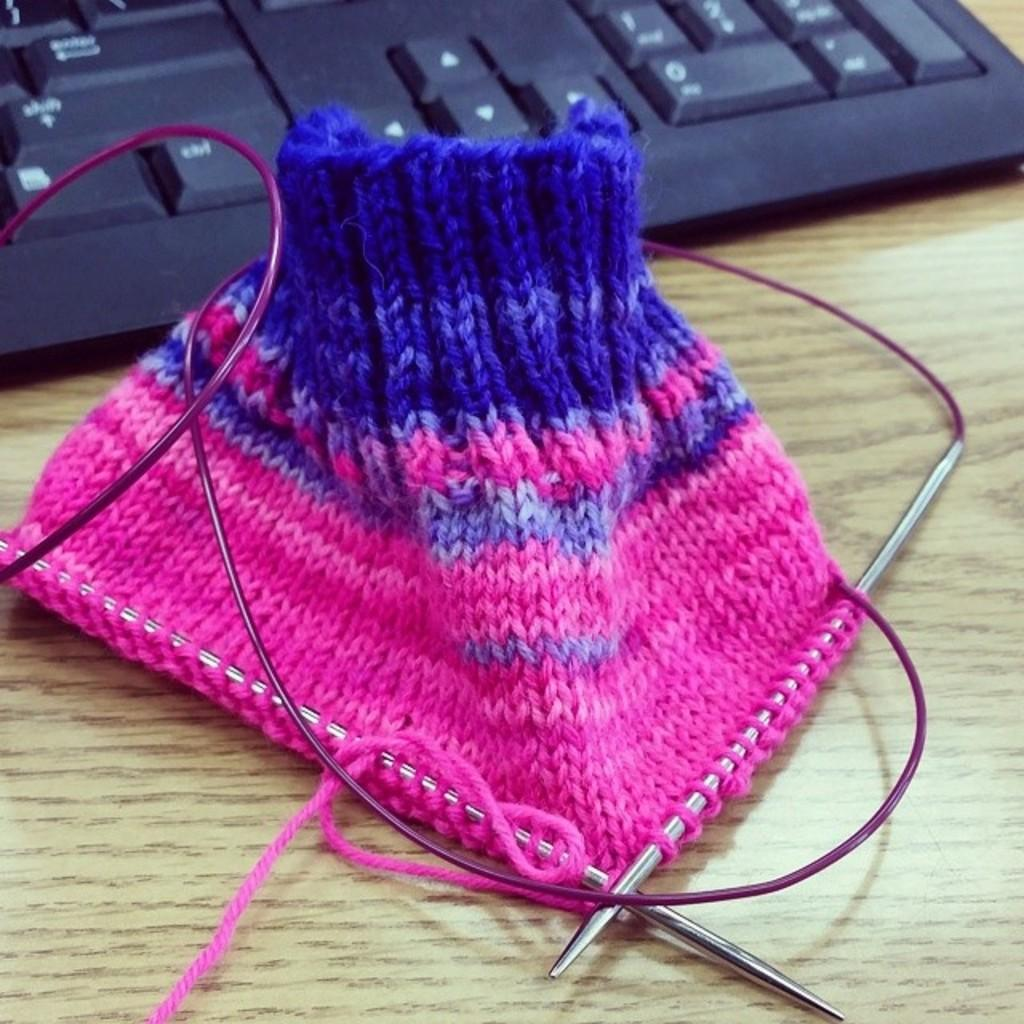What type of material is present in the image? There is cloth in the image. What tools are used for sewing that can be seen in the image? Sewing needles are visible in the image. What electronic device is present in the image? There is a keyboard in the image. What surface are the objects placed on in the image? The objects are on a wooden platform. What type of pail is used to serve the stew in the image? There is no pail or stew present in the image. How does the skate interact with the cloth in the image? There is no skate present in the image, so it cannot interact with the cloth. 